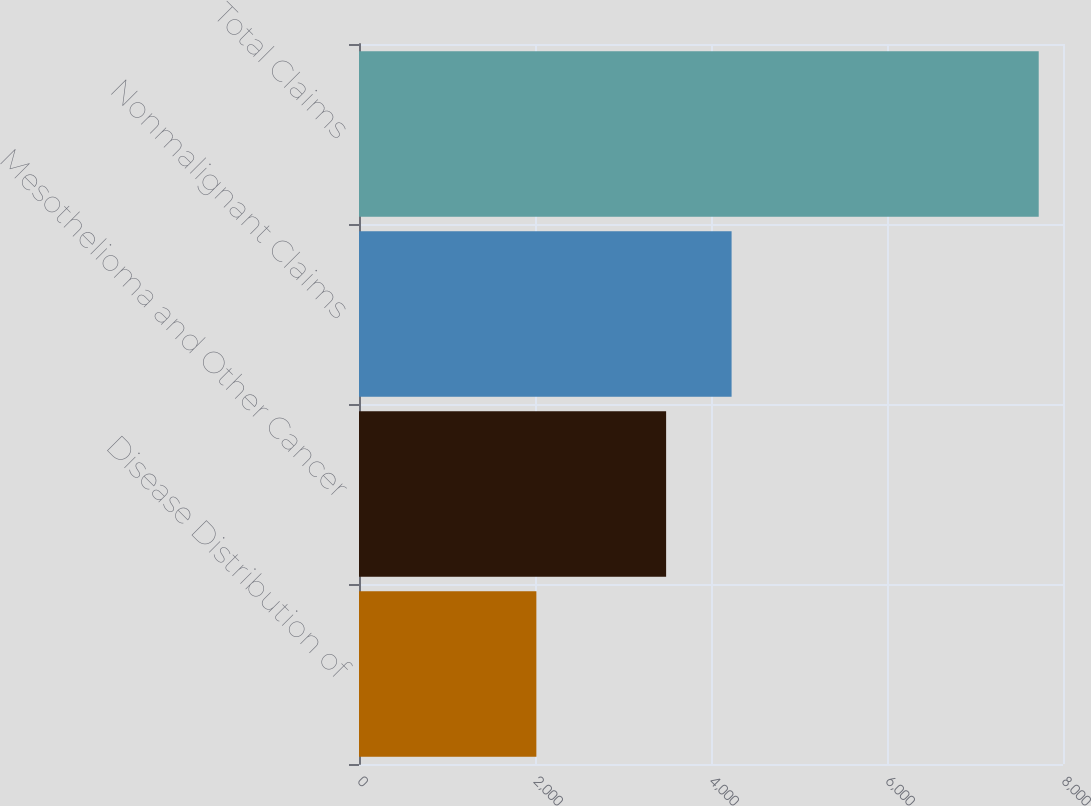Convert chart. <chart><loc_0><loc_0><loc_500><loc_500><bar_chart><fcel>Disease Distribution of<fcel>Mesothelioma and Other Cancer<fcel>Nonmalignant Claims<fcel>Total Claims<nl><fcel>2016<fcel>3490<fcel>4234<fcel>7724<nl></chart> 